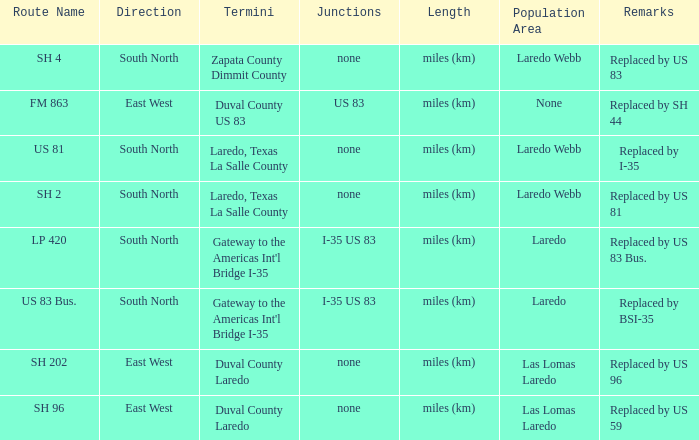What unit of length is being used for the route with "replaced by us 81" in their remarks section? Miles (km). 